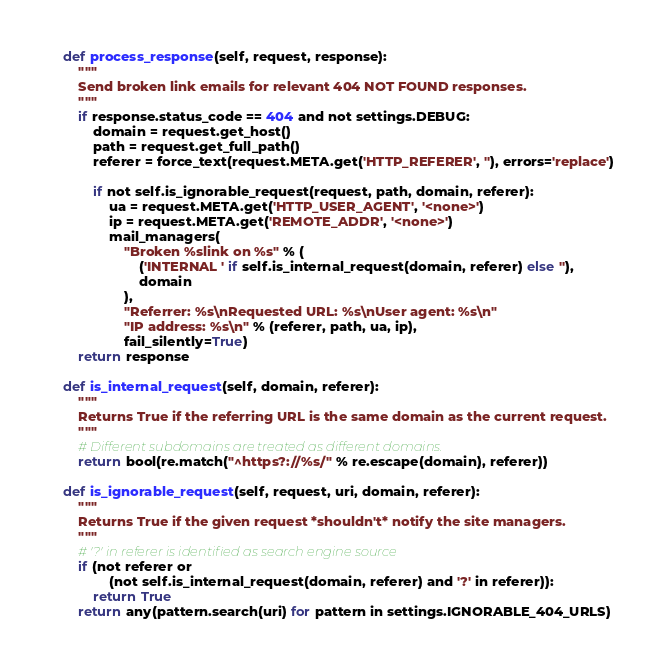Convert code to text. <code><loc_0><loc_0><loc_500><loc_500><_Python_>    def process_response(self, request, response):
        """
        Send broken link emails for relevant 404 NOT FOUND responses.
        """
        if response.status_code == 404 and not settings.DEBUG:
            domain = request.get_host()
            path = request.get_full_path()
            referer = force_text(request.META.get('HTTP_REFERER', ''), errors='replace')

            if not self.is_ignorable_request(request, path, domain, referer):
                ua = request.META.get('HTTP_USER_AGENT', '<none>')
                ip = request.META.get('REMOTE_ADDR', '<none>')
                mail_managers(
                    "Broken %slink on %s" % (
                        ('INTERNAL ' if self.is_internal_request(domain, referer) else ''),
                        domain
                    ),
                    "Referrer: %s\nRequested URL: %s\nUser agent: %s\n"
                    "IP address: %s\n" % (referer, path, ua, ip),
                    fail_silently=True)
        return response

    def is_internal_request(self, domain, referer):
        """
        Returns True if the referring URL is the same domain as the current request.
        """
        # Different subdomains are treated as different domains.
        return bool(re.match("^https?://%s/" % re.escape(domain), referer))

    def is_ignorable_request(self, request, uri, domain, referer):
        """
        Returns True if the given request *shouldn't* notify the site managers.
        """
        # '?' in referer is identified as search engine source
        if (not referer or
                (not self.is_internal_request(domain, referer) and '?' in referer)):
            return True
        return any(pattern.search(uri) for pattern in settings.IGNORABLE_404_URLS)
</code> 